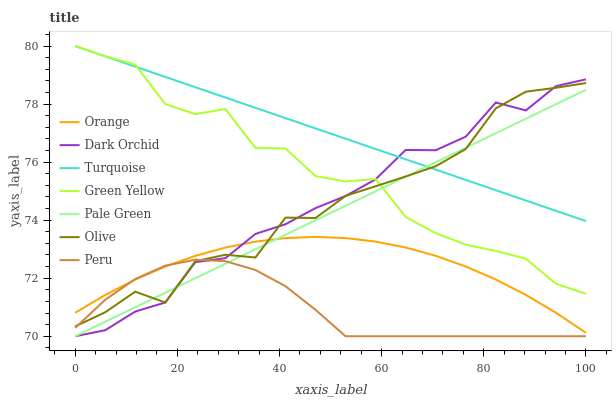Does Peru have the minimum area under the curve?
Answer yes or no. Yes. Does Turquoise have the maximum area under the curve?
Answer yes or no. Yes. Does Dark Orchid have the minimum area under the curve?
Answer yes or no. No. Does Dark Orchid have the maximum area under the curve?
Answer yes or no. No. Is Turquoise the smoothest?
Answer yes or no. Yes. Is Green Yellow the roughest?
Answer yes or no. Yes. Is Dark Orchid the smoothest?
Answer yes or no. No. Is Dark Orchid the roughest?
Answer yes or no. No. Does Dark Orchid have the lowest value?
Answer yes or no. Yes. Does Olive have the lowest value?
Answer yes or no. No. Does Green Yellow have the highest value?
Answer yes or no. Yes. Does Dark Orchid have the highest value?
Answer yes or no. No. Is Peru less than Green Yellow?
Answer yes or no. Yes. Is Turquoise greater than Peru?
Answer yes or no. Yes. Does Turquoise intersect Pale Green?
Answer yes or no. Yes. Is Turquoise less than Pale Green?
Answer yes or no. No. Is Turquoise greater than Pale Green?
Answer yes or no. No. Does Peru intersect Green Yellow?
Answer yes or no. No. 